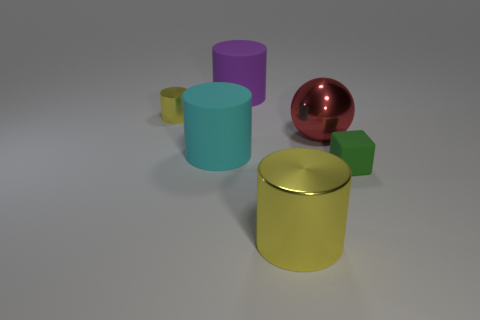Subtract all purple cylinders. How many cylinders are left? 3 Add 2 purple cylinders. How many objects exist? 8 Subtract all purple cylinders. How many cylinders are left? 3 Subtract all balls. How many objects are left? 5 Subtract all purple cubes. Subtract all gray cylinders. How many cubes are left? 1 Subtract all red cubes. How many green balls are left? 0 Subtract all metallic cylinders. Subtract all big metallic cylinders. How many objects are left? 3 Add 5 tiny cylinders. How many tiny cylinders are left? 6 Add 2 small green rubber things. How many small green rubber things exist? 3 Subtract 0 purple cubes. How many objects are left? 6 